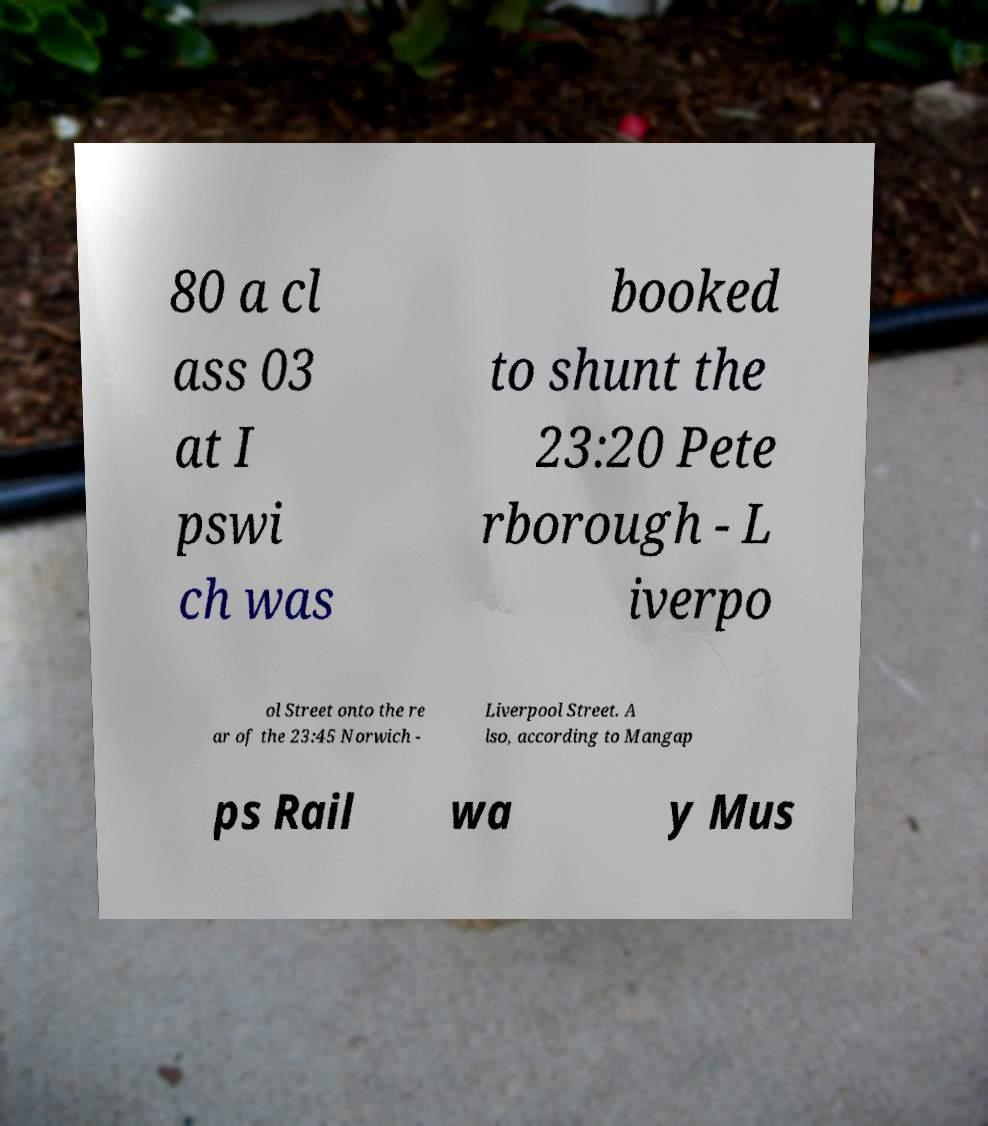Please identify and transcribe the text found in this image. 80 a cl ass 03 at I pswi ch was booked to shunt the 23:20 Pete rborough - L iverpo ol Street onto the re ar of the 23:45 Norwich - Liverpool Street. A lso, according to Mangap ps Rail wa y Mus 